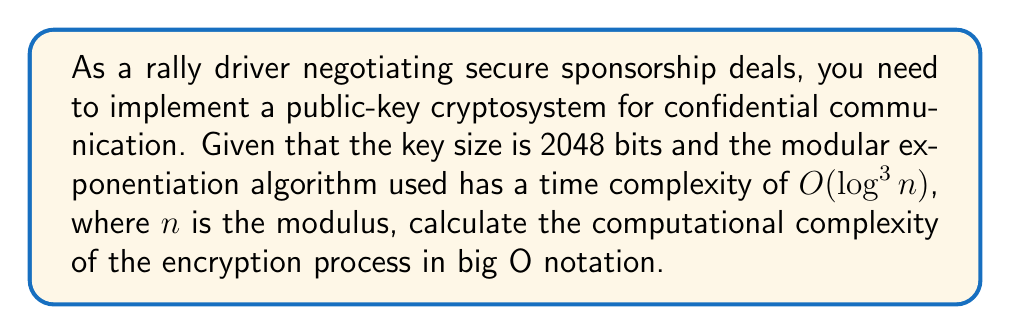Show me your answer to this math problem. To solve this problem, we'll follow these steps:

1) In public-key cryptosystems, the key size typically corresponds to the size of the modulus $n$. So, we have:

   $n = 2^{2048}$

2) The time complexity of the modular exponentiation algorithm is given as $O(\log^3 n)$.

3) We need to express $\log n$ in terms of the key size:

   $\log n = \log (2^{2048}) = 2048 \log 2$

4) Substituting this into the time complexity formula:

   $O(\log^3 n) = O((2048 \log 2)^3)$

5) Simplify:

   $O((2048 \log 2)^3) = O(2048^3 \cdot (\log 2)^3)$

6) $(\log 2)^3$ is a constant, so we can drop it in big O notation:

   $O(2048^3) = O(k^3)$, where $k$ is the key size in bits

Therefore, the computational complexity of the encryption process is $O(k^3)$, where $k$ is the key size in bits.
Answer: $O(k^3)$ 